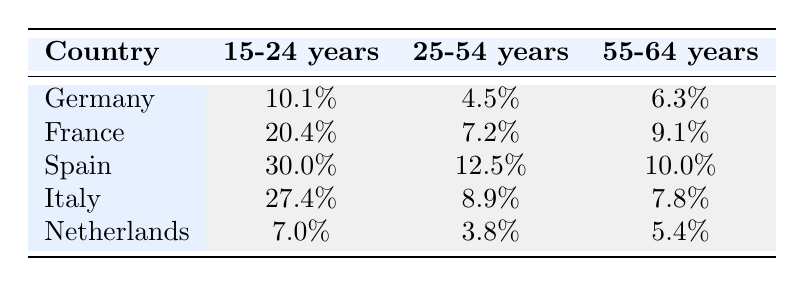What is the highest unemployment rate for the age group 15-24? By looking at the table, the unemployment rates for the 15-24 age group are: Germany 10.1%, France 20.4%, Spain 30.0%, Italy 27.4%, and Netherlands 7.0%. The highest of these values is 30.0%, which belongs to Spain.
Answer: 30.0% Which country has the lowest unemployment rate for the age group 25-54? The unemployment rates in the age group 25-54 are: Germany 4.5%, France 7.2%, Spain 12.5%, Italy 8.9%, and Netherlands 3.8%. The lowest unemployment rate in this group is 3.8%, which is for the Netherlands.
Answer: Netherlands What is the average unemployment rate for the age group 55-64 across the five countries? The unemployment rates for the age group 55-64 are: Germany 6.3%, France 9.1%, Spain 10.0%, Italy 7.8%, and Netherlands 5.4%. To find the average, we sum these rates (6.3 + 9.1 + 10.0 + 7.8 + 5.4 = 38.6) and then divide by the number of countries (5). So, the average is 38.6 / 5 = 7.72%.
Answer: 7.72% Is the unemployment rate for the age group 15-24 in Italy higher than that in Germany? From the table, the unemployment rate for the 15-24 age group in Italy is 27.4%, while in Germany it is 10.1%. Since 27.4% is greater than 10.1%, the statement is true.
Answer: Yes In which age group does France have the highest unemployment rate? The unemployment rates for France across the age groups are: 15-24 years 20.4%, 25-54 years 7.2%, and 55-64 years 9.1%. The highest unemployment rate is 20.4% in the 15-24 age group.
Answer: 15-24 years 